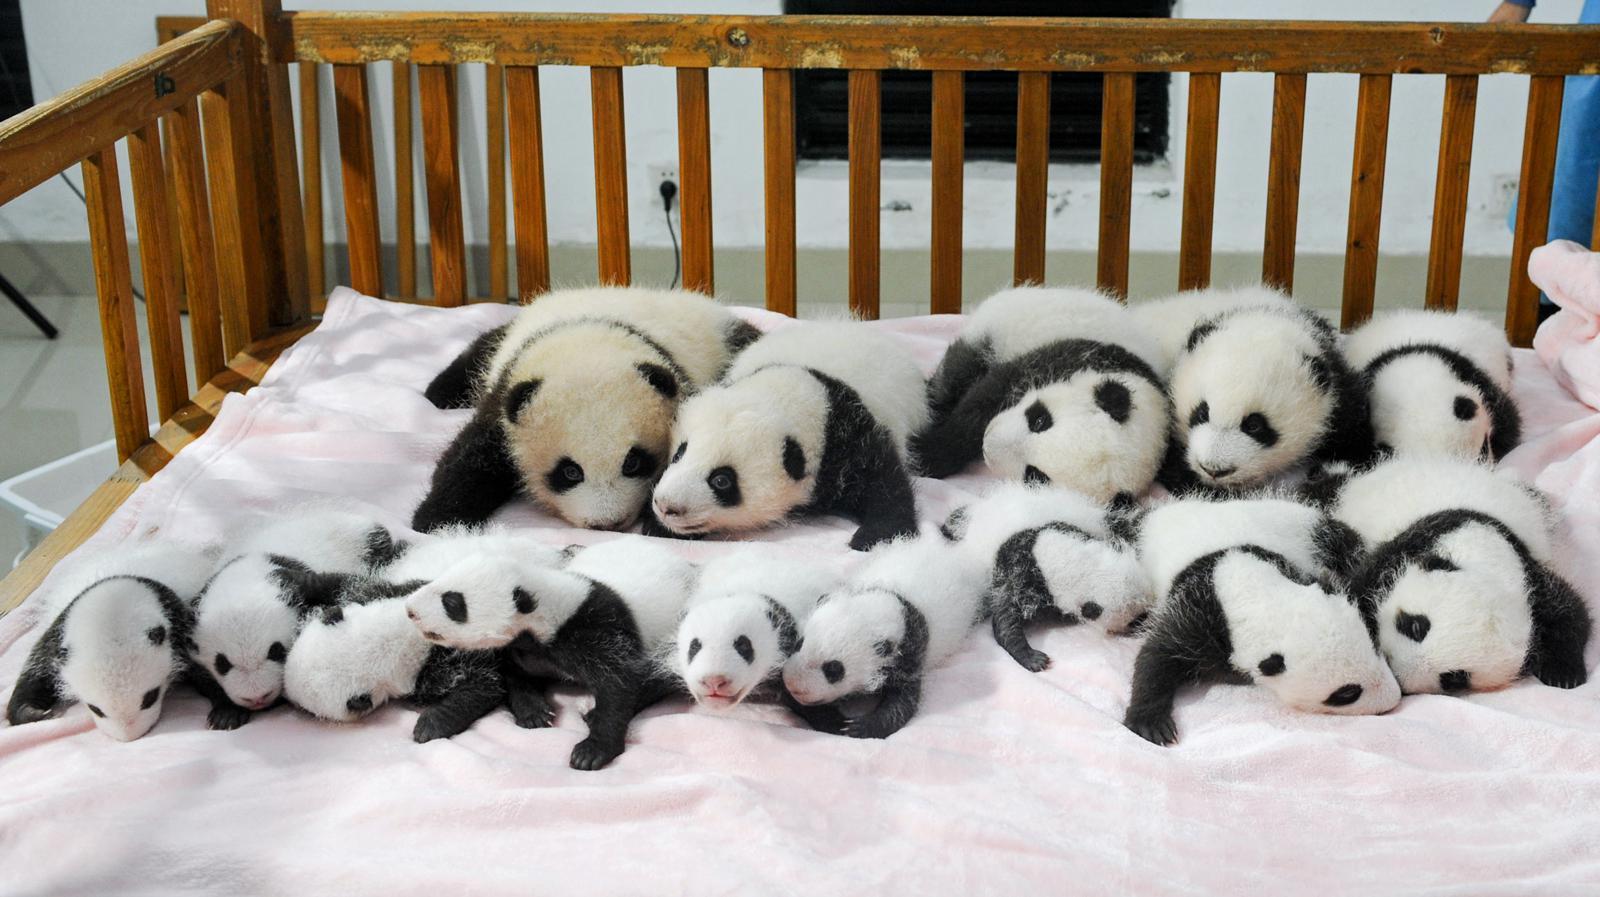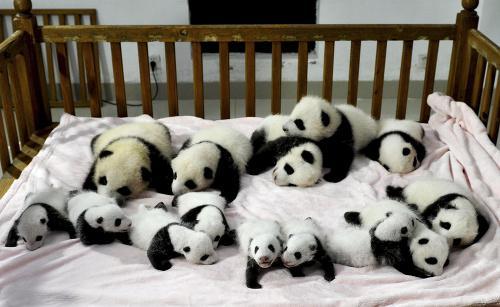The first image is the image on the left, the second image is the image on the right. For the images shown, is this caption "Exactly two pandas are playing in the snow in one of the images." true? Answer yes or no. No. The first image is the image on the left, the second image is the image on the right. Given the left and right images, does the statement "At least one image shows many pandas on a white blanket surrounded by wooden rails, like a crib." hold true? Answer yes or no. Yes. 